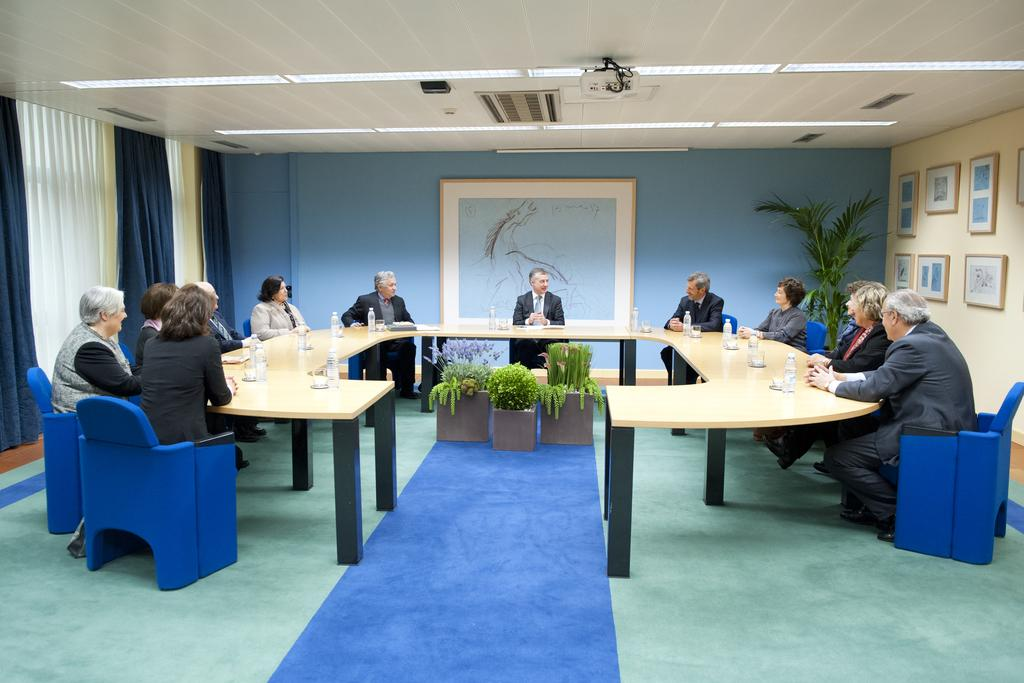How many people are in the image? There is a group of people in the image. What are the people doing in the image? The people are sitting in chairs. What is in front of the people? There is a table in front of the people. What can be found on the table? The table has water bottles on it. What color is the background wall in the image? The background wall is blue in color. Where is the alley located in the image? There is no alley present in the image. What type of toothbrush is being used by the people in the image? There are no toothbrushes visible in the image. 